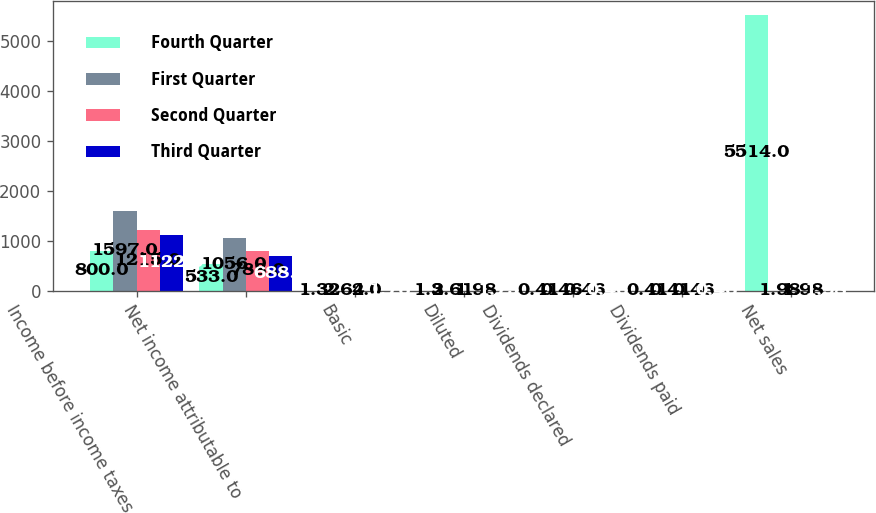Convert chart. <chart><loc_0><loc_0><loc_500><loc_500><stacked_bar_chart><ecel><fcel>Income before income taxes<fcel>Net income attributable to<fcel>Basic<fcel>Diluted<fcel>Dividends declared<fcel>Dividends paid<fcel>Net sales<nl><fcel>Fourth Quarter<fcel>800<fcel>533<fcel>1.32<fcel>1.3<fcel>0.41<fcel>0.41<fcel>5514<nl><fcel>First Quarter<fcel>1597<fcel>1056<fcel>2.64<fcel>2.61<fcel>0.46<fcel>0.41<fcel>1.98<nl><fcel>Second Quarter<fcel>1215<fcel>788<fcel>2<fcel>1.98<fcel>0.46<fcel>0.46<fcel>1.98<nl><fcel>Third Quarter<fcel>1122<fcel>688<fcel>1.76<fcel>1.75<fcel>0.46<fcel>0.46<fcel>1.98<nl></chart> 